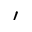Convert formula to latex. <formula><loc_0><loc_0><loc_500><loc_500>\prime</formula> 